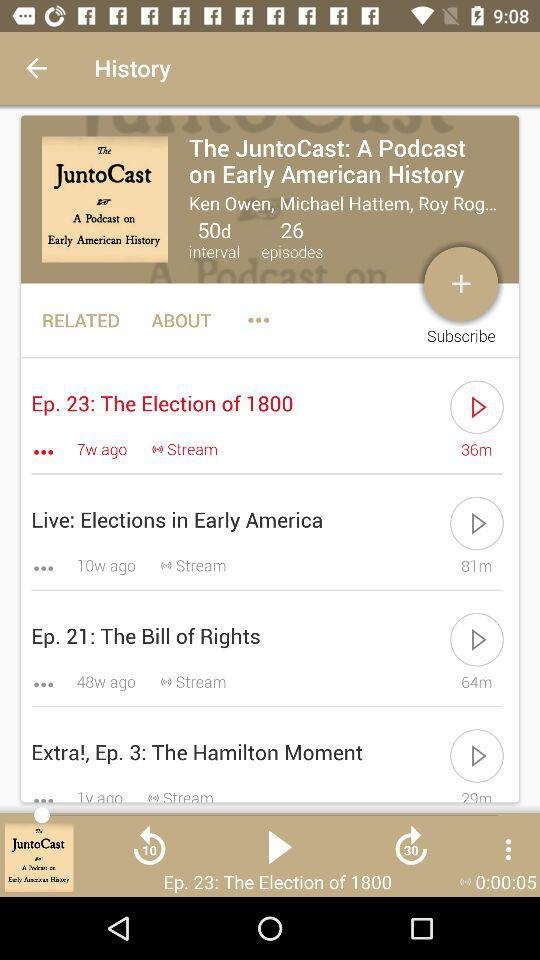What is the number of selected episode? The selected episode number is 23. 